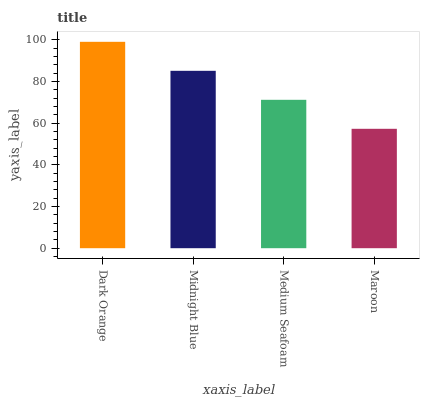Is Maroon the minimum?
Answer yes or no. Yes. Is Dark Orange the maximum?
Answer yes or no. Yes. Is Midnight Blue the minimum?
Answer yes or no. No. Is Midnight Blue the maximum?
Answer yes or no. No. Is Dark Orange greater than Midnight Blue?
Answer yes or no. Yes. Is Midnight Blue less than Dark Orange?
Answer yes or no. Yes. Is Midnight Blue greater than Dark Orange?
Answer yes or no. No. Is Dark Orange less than Midnight Blue?
Answer yes or no. No. Is Midnight Blue the high median?
Answer yes or no. Yes. Is Medium Seafoam the low median?
Answer yes or no. Yes. Is Maroon the high median?
Answer yes or no. No. Is Maroon the low median?
Answer yes or no. No. 